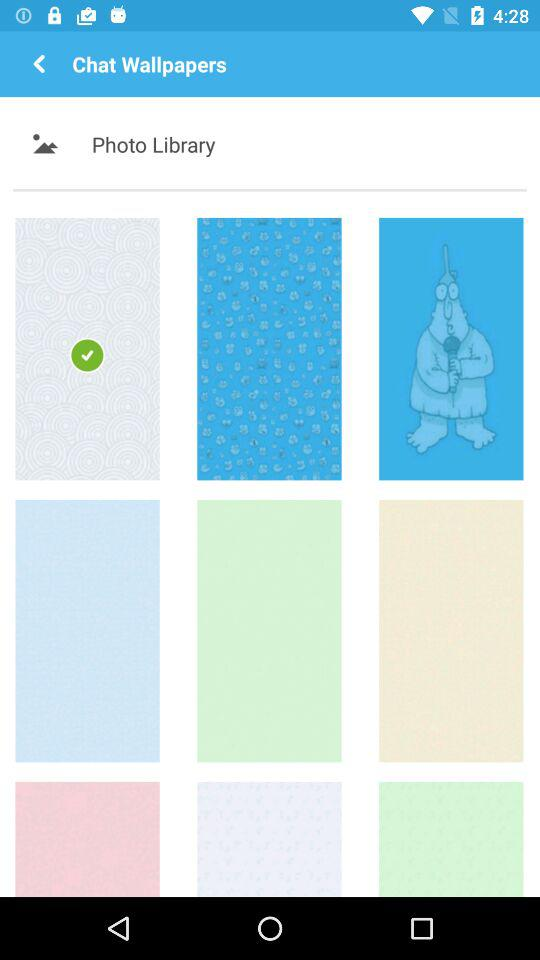Who is the user chatting with?
When the provided information is insufficient, respond with <no answer>. <no answer> 